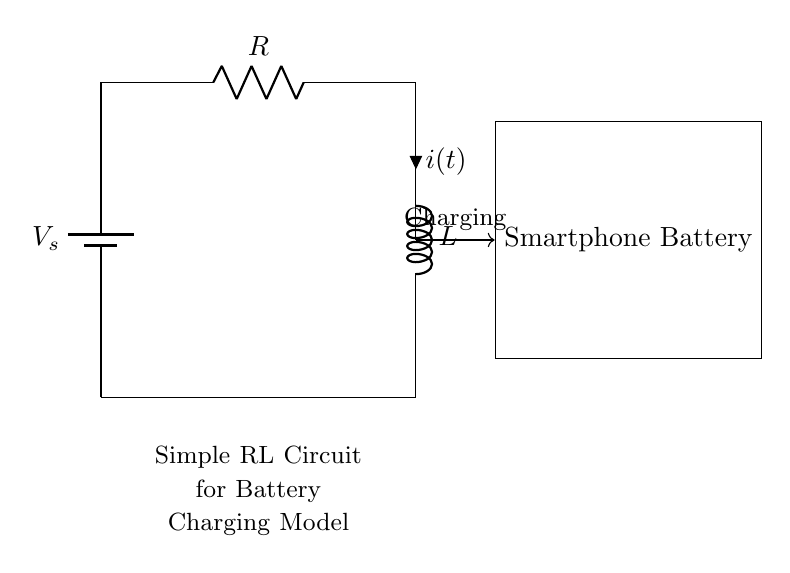What is the source voltage in the circuit? The source voltage, denoted as V_s, is the potential difference provided by the battery. In the diagram, it is represented next to the battery component.
Answer: V_s What components are present in the circuit? The key components present in this circuit are a battery, resistor, and inductor. These components are visually identifiable in the circuit diagram.
Answer: Battery, resistor, inductor What symbolizes the current in the circuit? The current is represented by the symbol 'i(t)', which indicates that the current in this RL circuit is time-dependent, as denoted by the 't' in the notation.
Answer: i(t) Describe the connection type between the resistor and inductor. The resistor and inductor are connected in series, meaning the same current flows through both components in a single pathway. This can be inferred as there are no branching paths between them.
Answer: Series What happens to the current when the circuit is first connected? Initially, the current starts at zero and gradually increases over time due to the inductor's property of opposing changes in current, which results in an exponential charging behavior of the battery.
Answer: Increases gradually What role does the inductor play in this circuit? The inductor acts to store energy in a magnetic field when current flows through it and opposes sudden changes in current flow, affecting the charging rate of the smartphone battery.
Answer: Stores energy 